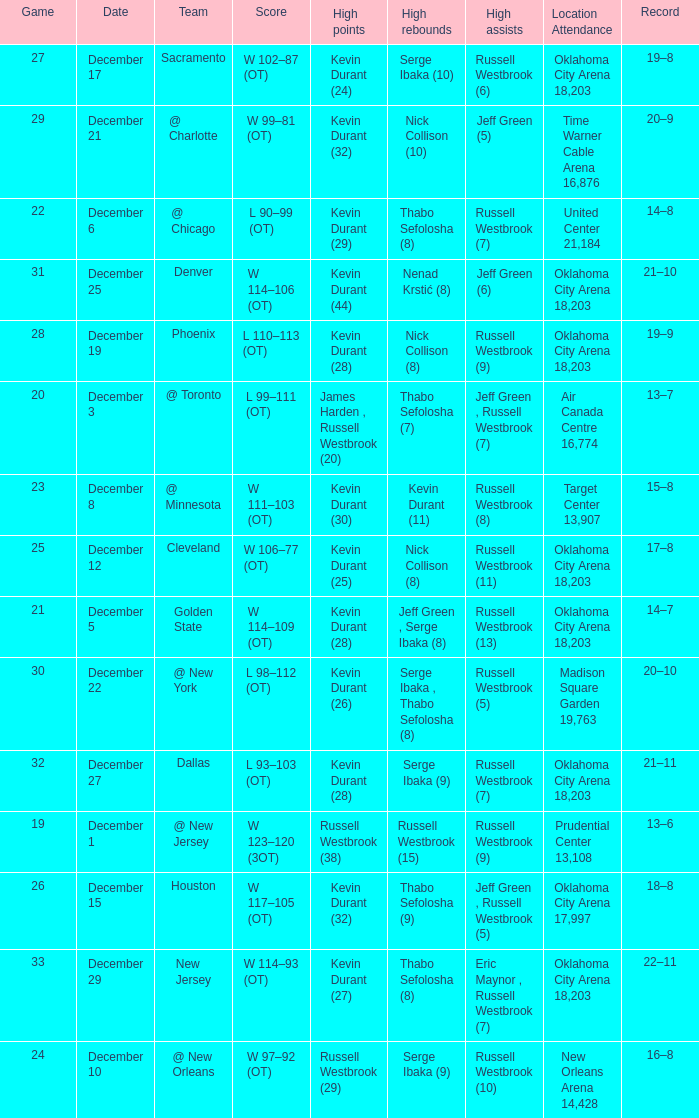What was the record on December 27? 21–11. 